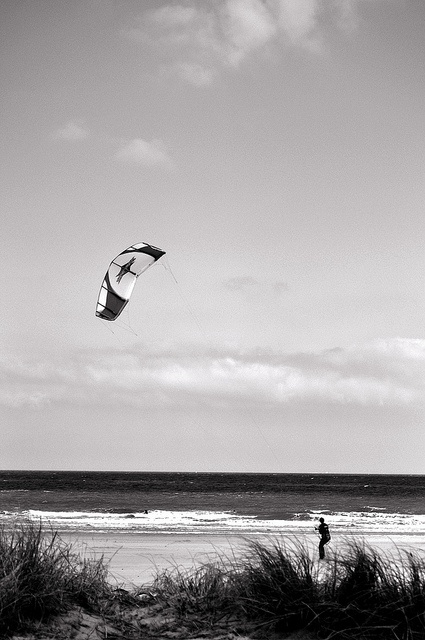Describe the objects in this image and their specific colors. I can see kite in gray, lightgray, black, and darkgray tones and people in gray, black, lightgray, and darkgray tones in this image. 